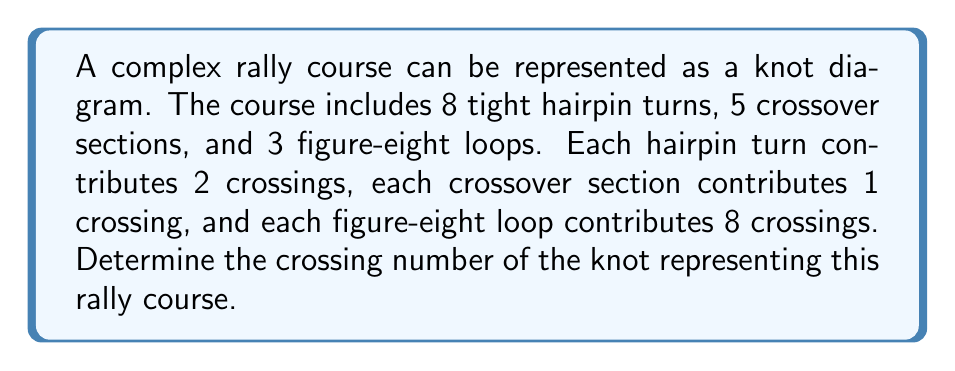Teach me how to tackle this problem. Let's break this down step-by-step:

1. Contributions from hairpin turns:
   - Each hairpin turn contributes 2 crossings
   - There are 8 hairpin turns
   - Total crossings from hairpin turns = $8 \times 2 = 16$

2. Contributions from crossover sections:
   - Each crossover section contributes 1 crossing
   - There are 5 crossover sections
   - Total crossings from crossover sections = $5 \times 1 = 5$

3. Contributions from figure-eight loops:
   - Each figure-eight loop contributes 8 crossings
   - There are 3 figure-eight loops
   - Total crossings from figure-eight loops = $3 \times 8 = 24$

4. Sum up all contributions:
   $$ \text{Total crossings} = 16 + 5 + 24 = 45 $$

Therefore, the crossing number of the knot representing this rally course is 45.
Answer: 45 